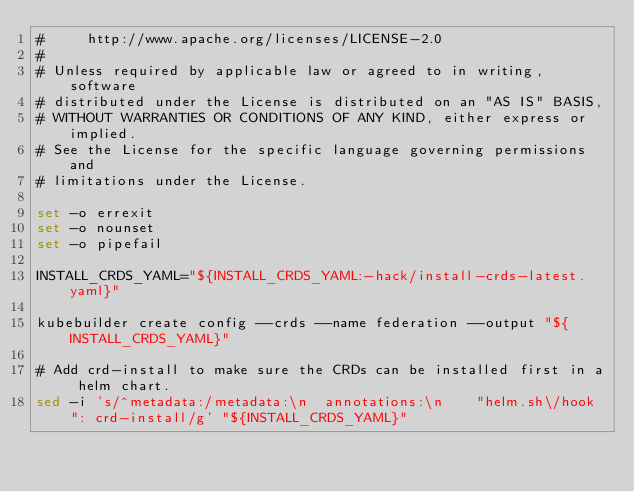Convert code to text. <code><loc_0><loc_0><loc_500><loc_500><_Bash_>#     http://www.apache.org/licenses/LICENSE-2.0
#
# Unless required by applicable law or agreed to in writing, software
# distributed under the License is distributed on an "AS IS" BASIS,
# WITHOUT WARRANTIES OR CONDITIONS OF ANY KIND, either express or implied.
# See the License for the specific language governing permissions and
# limitations under the License.

set -o errexit
set -o nounset
set -o pipefail

INSTALL_CRDS_YAML="${INSTALL_CRDS_YAML:-hack/install-crds-latest.yaml}"

kubebuilder create config --crds --name federation --output "${INSTALL_CRDS_YAML}"

# Add crd-install to make sure the CRDs can be installed first in a helm chart.
sed -i 's/^metadata:/metadata:\n  annotations:\n    "helm.sh\/hook": crd-install/g' "${INSTALL_CRDS_YAML}"
</code> 